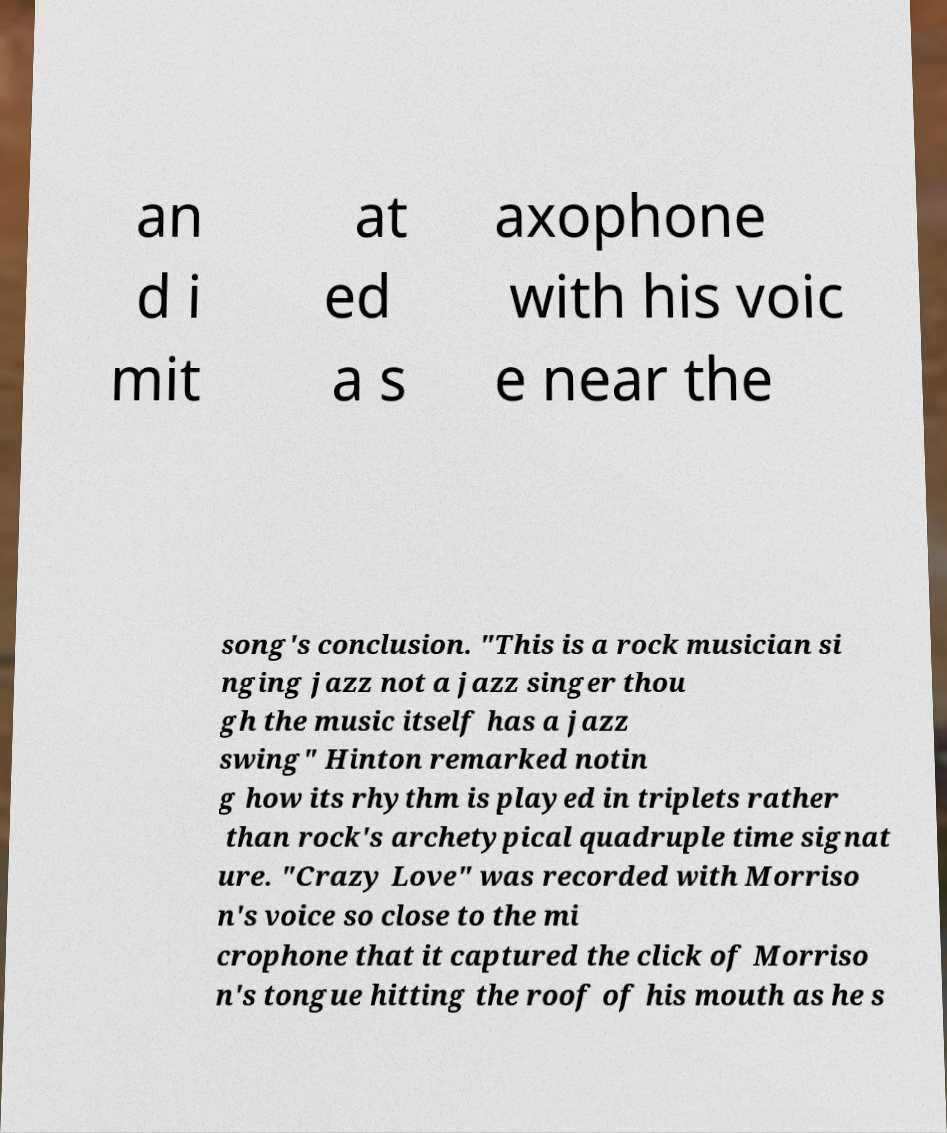For documentation purposes, I need the text within this image transcribed. Could you provide that? an d i mit at ed a s axophone with his voic e near the song's conclusion. "This is a rock musician si nging jazz not a jazz singer thou gh the music itself has a jazz swing" Hinton remarked notin g how its rhythm is played in triplets rather than rock's archetypical quadruple time signat ure. "Crazy Love" was recorded with Morriso n's voice so close to the mi crophone that it captured the click of Morriso n's tongue hitting the roof of his mouth as he s 